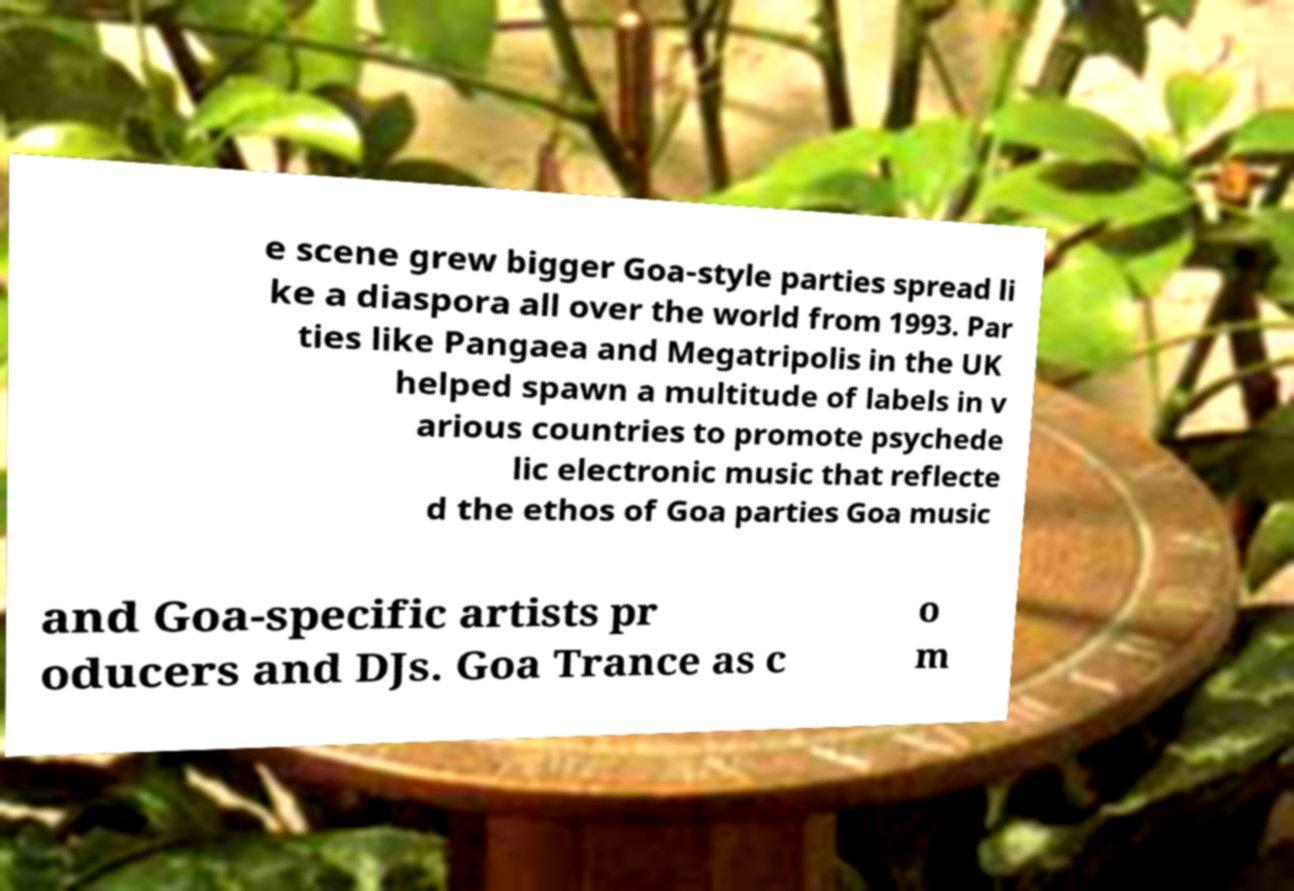Please identify and transcribe the text found in this image. e scene grew bigger Goa-style parties spread li ke a diaspora all over the world from 1993. Par ties like Pangaea and Megatripolis in the UK helped spawn a multitude of labels in v arious countries to promote psychede lic electronic music that reflecte d the ethos of Goa parties Goa music and Goa-specific artists pr oducers and DJs. Goa Trance as c o m 